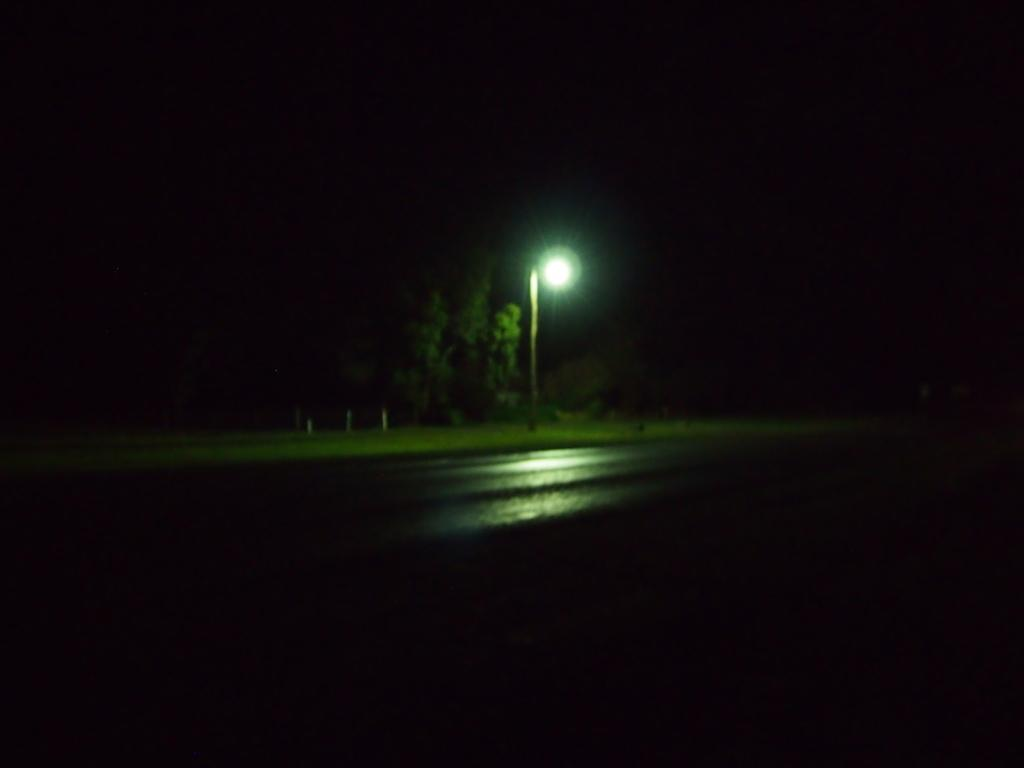What structure is visible in the image? There is a light pole in the image. What type of natural elements can be seen in the image? There are trees in the image. How would you describe the lighting conditions in the image? The background of the image is dark. What type of instrument is being played by the bears in the image? There are no bears or instruments present in the image. 